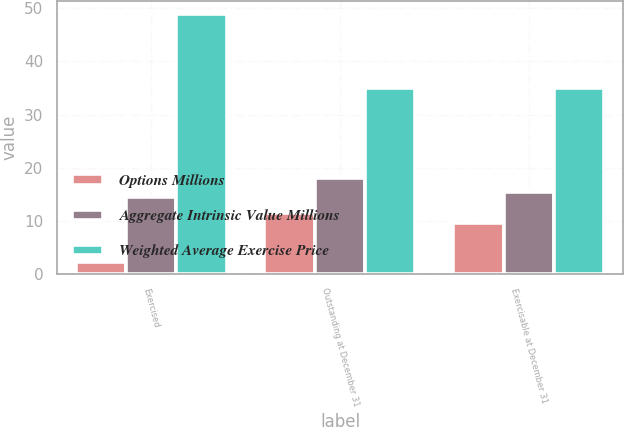Convert chart. <chart><loc_0><loc_0><loc_500><loc_500><stacked_bar_chart><ecel><fcel>Exercised<fcel>Outstanding at December 31<fcel>Exercisable at December 31<nl><fcel>Options Millions<fcel>2.3<fcel>11.5<fcel>9.6<nl><fcel>Aggregate Intrinsic Value Millions<fcel>14.45<fcel>18.1<fcel>15.44<nl><fcel>Weighted Average Exercise Price<fcel>49<fcel>35<fcel>35<nl></chart> 